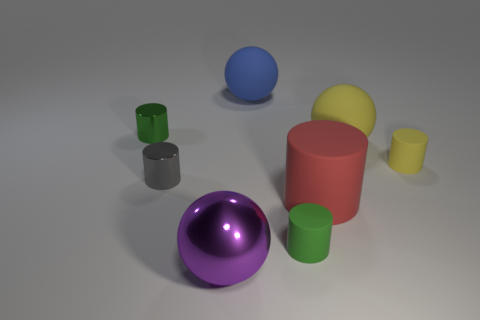What shape is the large blue object?
Your answer should be very brief. Sphere. Are there more large blue matte spheres to the left of the purple object than small gray objects behind the red object?
Provide a short and direct response. No. How many other things are there of the same size as the gray cylinder?
Your answer should be very brief. 3. What is the material of the thing that is both left of the yellow rubber cylinder and to the right of the big red cylinder?
Keep it short and to the point. Rubber. There is a big yellow thing that is the same shape as the big purple shiny thing; what material is it?
Your response must be concise. Rubber. What number of shiny objects are on the right side of the small rubber cylinder that is behind the green object that is on the right side of the large purple sphere?
Provide a short and direct response. 0. Are there any other things that have the same color as the big metal sphere?
Keep it short and to the point. No. How many large spheres are in front of the small green metal cylinder and on the right side of the purple object?
Your response must be concise. 1. Does the green cylinder that is in front of the tiny gray object have the same size as the green cylinder that is on the left side of the small green matte cylinder?
Your response must be concise. Yes. What number of objects are either metallic cylinders behind the tiny gray object or large blue rubber cubes?
Offer a very short reply. 1. 